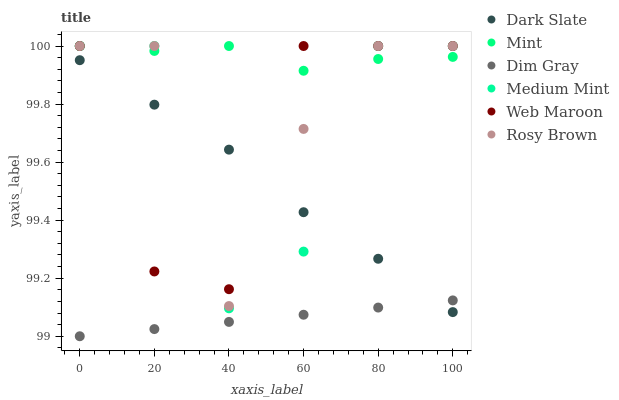Does Dim Gray have the minimum area under the curve?
Answer yes or no. Yes. Does Mint have the maximum area under the curve?
Answer yes or no. Yes. Does Rosy Brown have the minimum area under the curve?
Answer yes or no. No. Does Rosy Brown have the maximum area under the curve?
Answer yes or no. No. Is Dim Gray the smoothest?
Answer yes or no. Yes. Is Medium Mint the roughest?
Answer yes or no. Yes. Is Rosy Brown the smoothest?
Answer yes or no. No. Is Rosy Brown the roughest?
Answer yes or no. No. Does Dim Gray have the lowest value?
Answer yes or no. Yes. Does Rosy Brown have the lowest value?
Answer yes or no. No. Does Mint have the highest value?
Answer yes or no. Yes. Does Dim Gray have the highest value?
Answer yes or no. No. Is Dim Gray less than Mint?
Answer yes or no. Yes. Is Rosy Brown greater than Dim Gray?
Answer yes or no. Yes. Does Dark Slate intersect Dim Gray?
Answer yes or no. Yes. Is Dark Slate less than Dim Gray?
Answer yes or no. No. Is Dark Slate greater than Dim Gray?
Answer yes or no. No. Does Dim Gray intersect Mint?
Answer yes or no. No. 